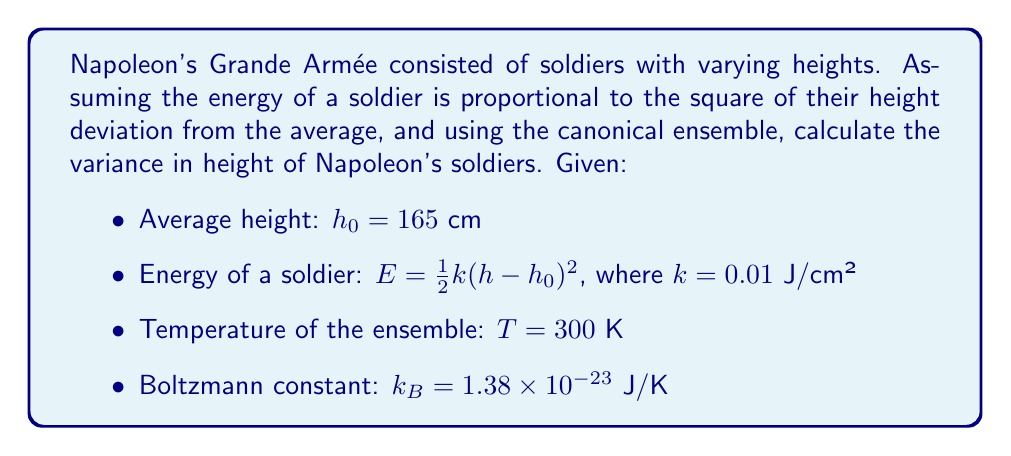Can you solve this math problem? 1. In the canonical ensemble, the probability distribution is given by:
   $$P(h) \propto e^{-\beta E(h)}$$
   where $\beta = \frac{1}{k_B T}$

2. The energy is quadratic in $h$, so this is a Gaussian distribution:
   $$P(h) \propto e^{-\frac{\beta k}{2}(h-h_0)^2}$$

3. For a Gaussian distribution, the variance $\sigma^2$ is related to the coefficient of $(h-h_0)^2$ by:
   $$\sigma^2 = \frac{1}{\beta k}$$

4. Calculate $\beta$:
   $$\beta = \frac{1}{k_B T} = \frac{1}{(1.38 \times 10^{-23} \text{ J/K})(300 \text{ K})} = 2.42 \times 10^{20} \text{ J}^{-1}$$

5. Calculate the variance:
   $$\sigma^2 = \frac{1}{\beta k} = \frac{1}{(2.42 \times 10^{20} \text{ J}^{-1})(0.01 \text{ J/cm}^2)} = 4.13 \text{ cm}^2$$

6. Take the square root to get the standard deviation:
   $$\sigma = \sqrt{4.13 \text{ cm}^2} = 2.03 \text{ cm}$$
Answer: 2.03 cm 